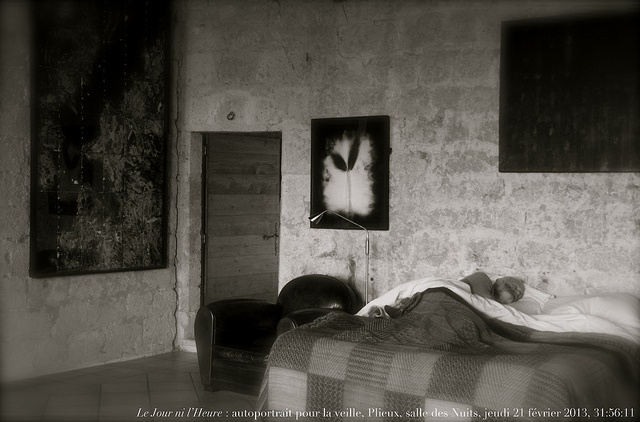Describe the objects in this image and their specific colors. I can see bed in black, gray, and darkgray tones, chair in black and gray tones, and people in black and gray tones in this image. 